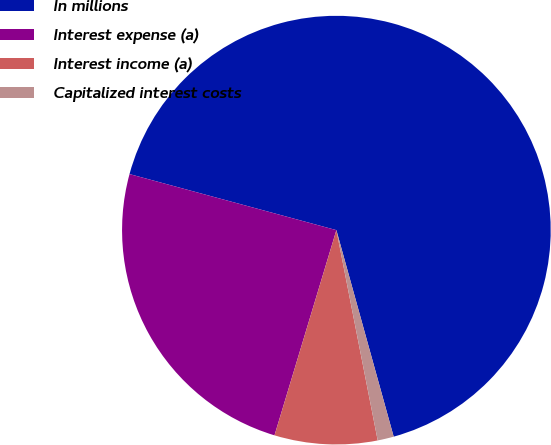Convert chart to OTSL. <chart><loc_0><loc_0><loc_500><loc_500><pie_chart><fcel>In millions<fcel>Interest expense (a)<fcel>Interest income (a)<fcel>Capitalized interest costs<nl><fcel>66.48%<fcel>24.55%<fcel>7.75%<fcel>1.22%<nl></chart> 